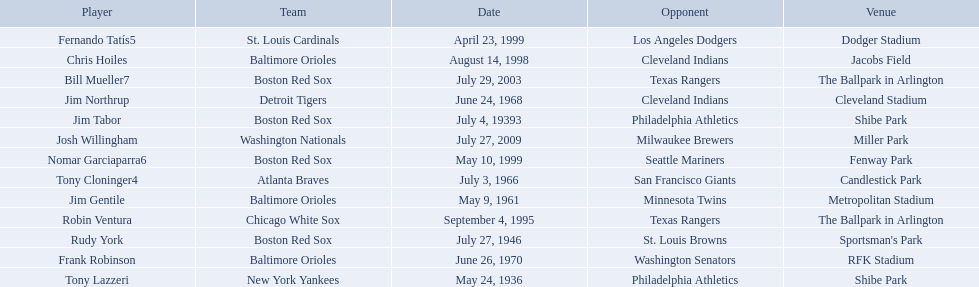What are the dates? May 24, 1936, July 4, 19393, July 27, 1946, May 9, 1961, July 3, 1966, June 24, 1968, June 26, 1970, September 4, 1995, August 14, 1998, April 23, 1999, May 10, 1999, July 29, 2003, July 27, 2009. Which date is in 1936? May 24, 1936. What player is listed for this date? Tony Lazzeri. Who were all the teams? New York Yankees, Boston Red Sox, Boston Red Sox, Baltimore Orioles, Atlanta Braves, Detroit Tigers, Baltimore Orioles, Chicago White Sox, Baltimore Orioles, St. Louis Cardinals, Boston Red Sox, Boston Red Sox, Washington Nationals. What about opponents? Philadelphia Athletics, Philadelphia Athletics, St. Louis Browns, Minnesota Twins, San Francisco Giants, Cleveland Indians, Washington Senators, Texas Rangers, Cleveland Indians, Los Angeles Dodgers, Seattle Mariners, Texas Rangers, Milwaukee Brewers. And when did they play? May 24, 1936, July 4, 19393, July 27, 1946, May 9, 1961, July 3, 1966, June 24, 1968, June 26, 1970, September 4, 1995, August 14, 1998, April 23, 1999, May 10, 1999, July 29, 2003, July 27, 2009. Which team played the red sox on july 27, 1946	? St. Louis Browns. 